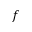<formula> <loc_0><loc_0><loc_500><loc_500>f</formula> 